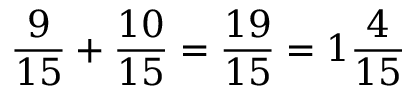Convert formula to latex. <formula><loc_0><loc_0><loc_500><loc_500>{ \frac { 9 } { 1 5 } } + { \frac { 1 0 } { 1 5 } } = { \frac { 1 9 } { 1 5 } } = 1 { \frac { 4 } { 1 5 } }</formula> 